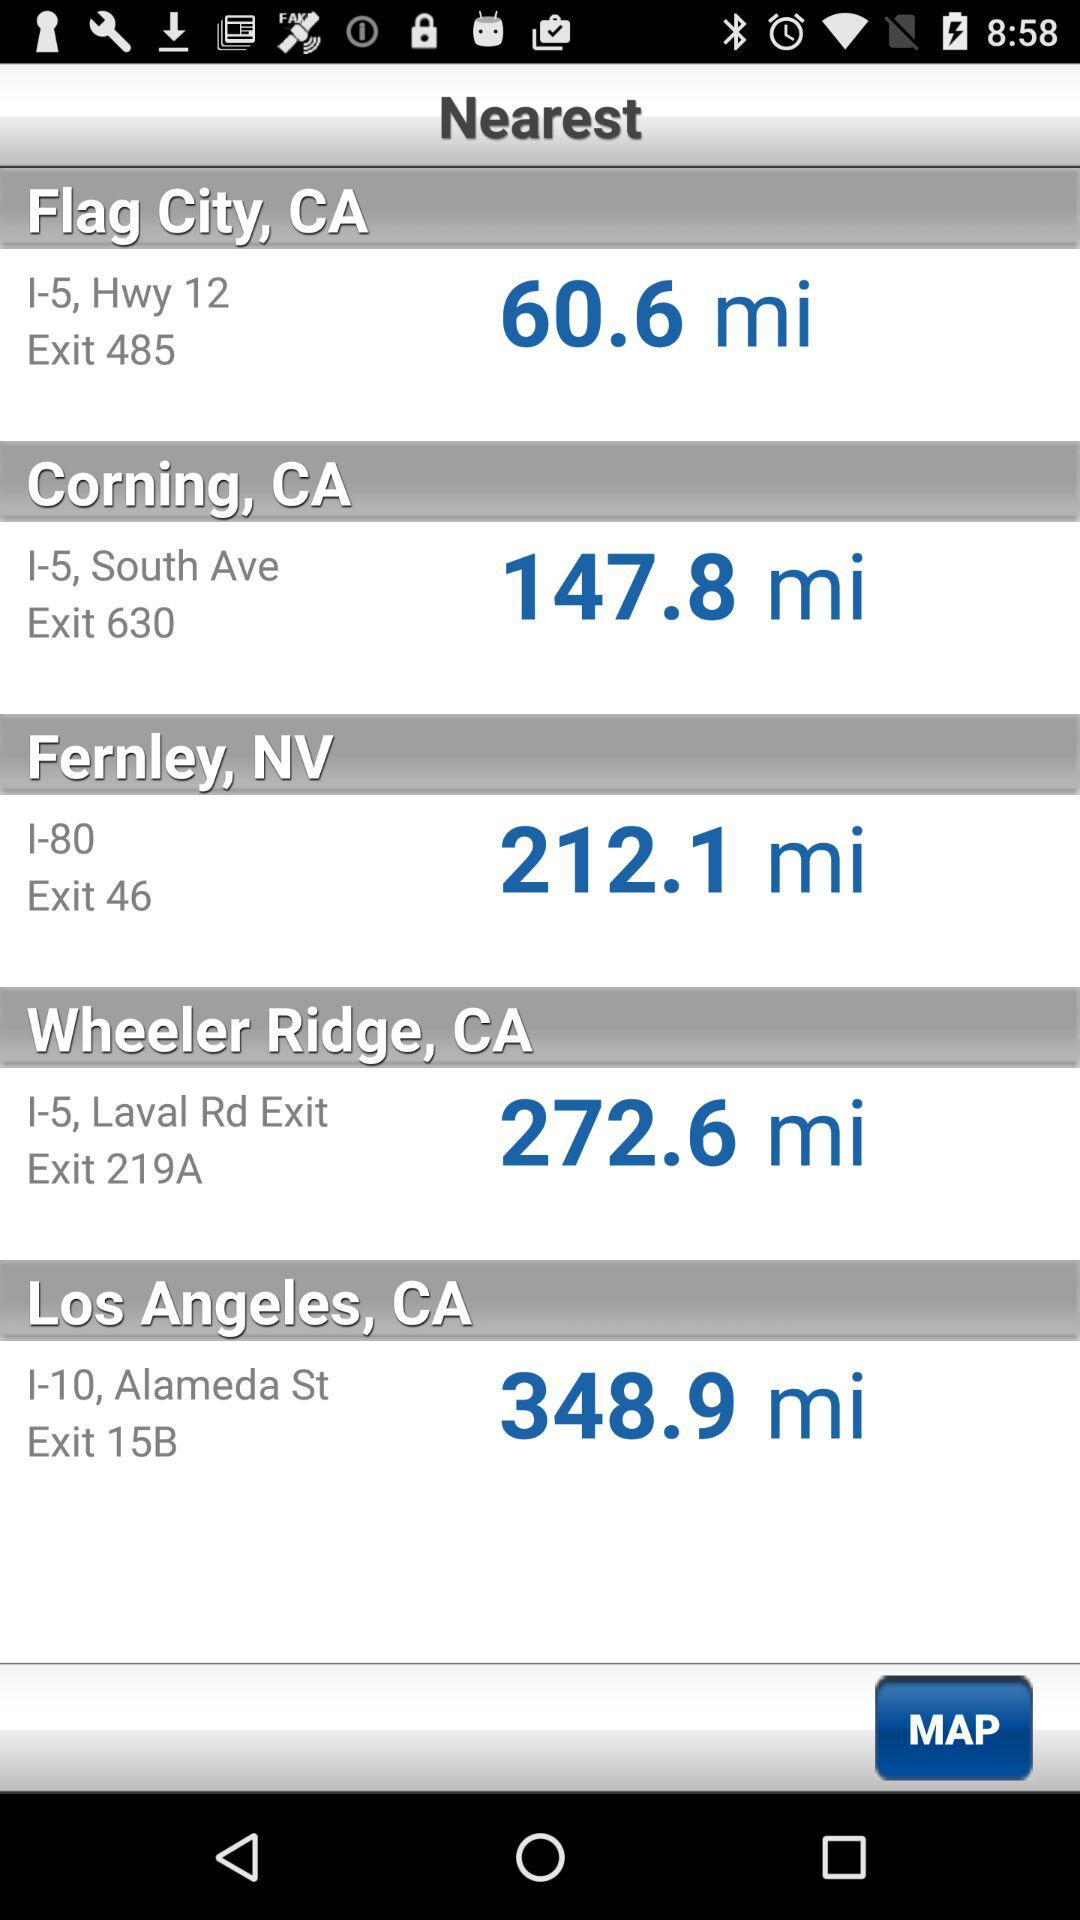Which city is further away, Wheeler Ridge, CA or Los Angeles, CA?
Answer the question using a single word or phrase. Los Angeles, CA 